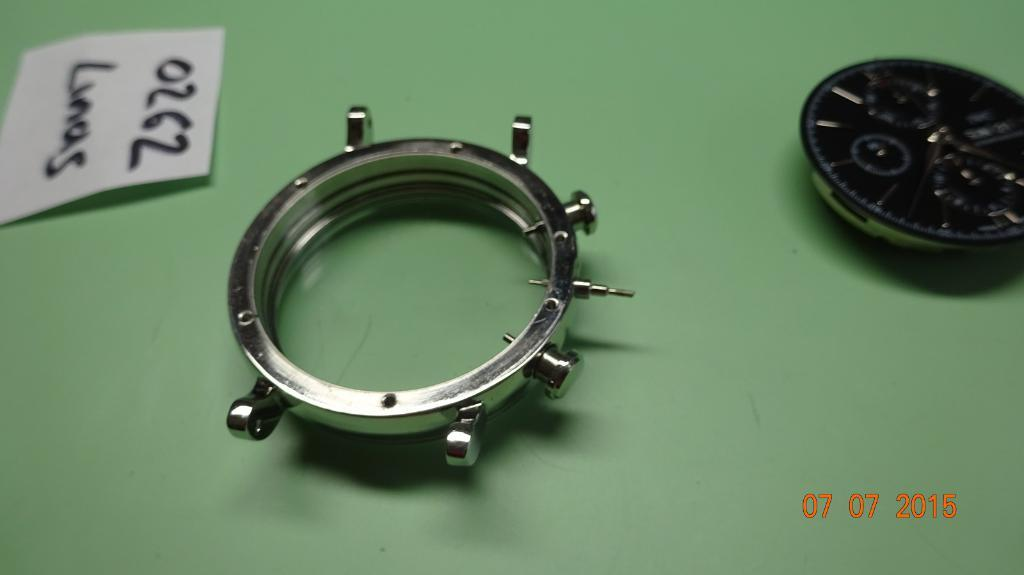<image>
Give a short and clear explanation of the subsequent image. A watch case sits next to a card with the number 0262 on it. 